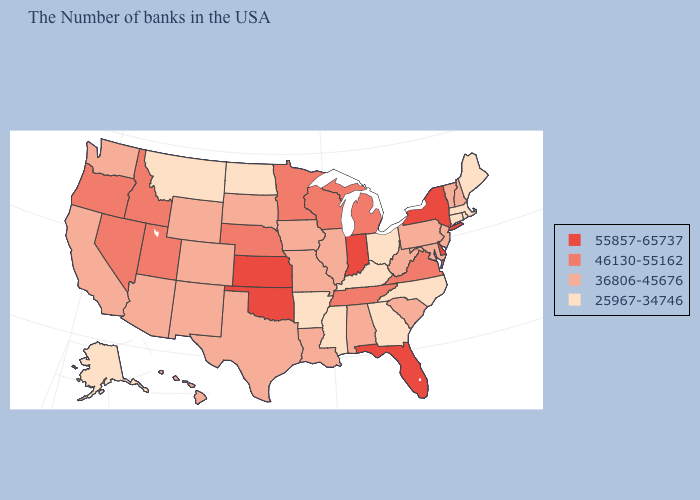What is the lowest value in states that border Missouri?
Quick response, please. 25967-34746. Name the states that have a value in the range 36806-45676?
Answer briefly. New Hampshire, Vermont, New Jersey, Maryland, Pennsylvania, South Carolina, West Virginia, Alabama, Illinois, Louisiana, Missouri, Iowa, Texas, South Dakota, Wyoming, Colorado, New Mexico, Arizona, California, Washington, Hawaii. What is the value of Wisconsin?
Give a very brief answer. 46130-55162. Does New Jersey have the highest value in the Northeast?
Quick response, please. No. Among the states that border Delaware , which have the highest value?
Give a very brief answer. New Jersey, Maryland, Pennsylvania. Among the states that border Alabama , does Florida have the highest value?
Quick response, please. Yes. What is the value of New Mexico?
Keep it brief. 36806-45676. What is the highest value in the USA?
Give a very brief answer. 55857-65737. Name the states that have a value in the range 55857-65737?
Answer briefly. New York, Delaware, Florida, Indiana, Kansas, Oklahoma. Does the map have missing data?
Answer briefly. No. Is the legend a continuous bar?
Give a very brief answer. No. Is the legend a continuous bar?
Concise answer only. No. What is the value of Nevada?
Concise answer only. 46130-55162. Name the states that have a value in the range 36806-45676?
Give a very brief answer. New Hampshire, Vermont, New Jersey, Maryland, Pennsylvania, South Carolina, West Virginia, Alabama, Illinois, Louisiana, Missouri, Iowa, Texas, South Dakota, Wyoming, Colorado, New Mexico, Arizona, California, Washington, Hawaii. How many symbols are there in the legend?
Be succinct. 4. 